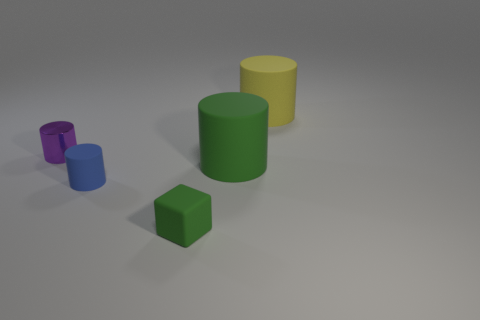Subtract all small purple cylinders. How many cylinders are left? 3 Add 5 tiny yellow matte spheres. How many objects exist? 10 Subtract all green cylinders. How many cylinders are left? 3 Subtract 2 cylinders. How many cylinders are left? 2 Add 3 small cylinders. How many small cylinders are left? 5 Add 3 green rubber cylinders. How many green rubber cylinders exist? 4 Subtract 1 green cubes. How many objects are left? 4 Subtract all cylinders. How many objects are left? 1 Subtract all purple cylinders. Subtract all gray blocks. How many cylinders are left? 3 Subtract all large yellow matte cylinders. Subtract all tiny blue cylinders. How many objects are left? 3 